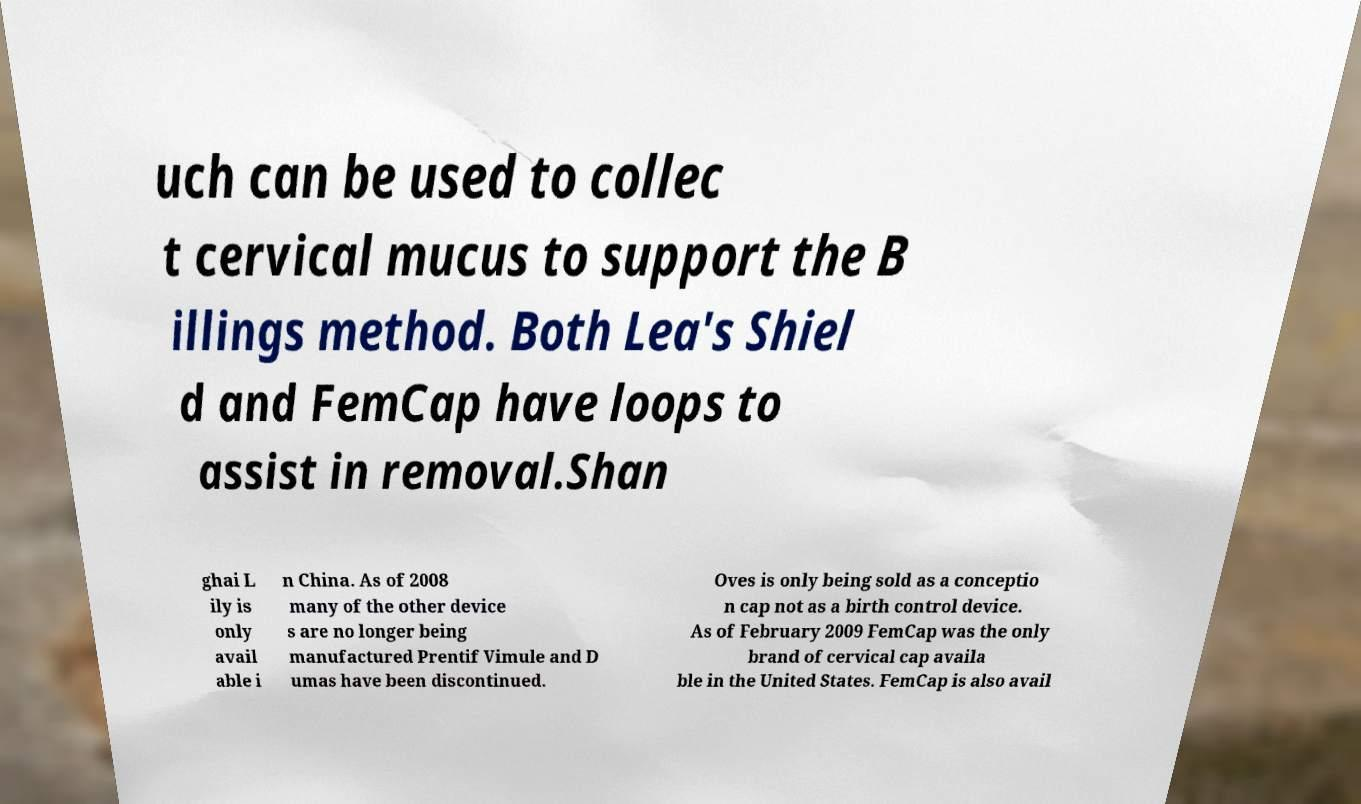Please identify and transcribe the text found in this image. uch can be used to collec t cervical mucus to support the B illings method. Both Lea's Shiel d and FemCap have loops to assist in removal.Shan ghai L ily is only avail able i n China. As of 2008 many of the other device s are no longer being manufactured Prentif Vimule and D umas have been discontinued. Oves is only being sold as a conceptio n cap not as a birth control device. As of February 2009 FemCap was the only brand of cervical cap availa ble in the United States. FemCap is also avail 